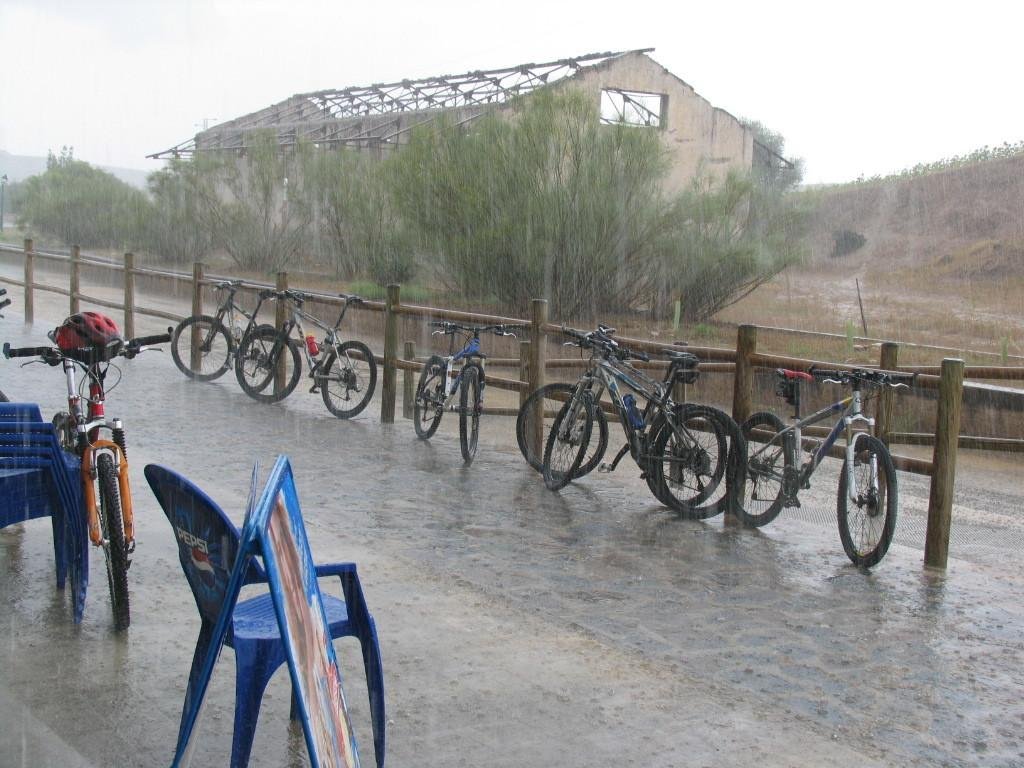What type of vehicles can be seen in the image? There are bicycles in the image. What type of furniture is present in the image? There are chairs in the image. What type of natural elements can be seen in the image? There are trees in the image. What type of building is visible in the image? There is a house in the image. What is visible in the background of the image? The sky is visible in the image. What type of crayon can be seen on the roof of the house in the image? There is no crayon present on the roof of the house in the image. What type of stone is visible in the image? There is no stone visible in the image. 